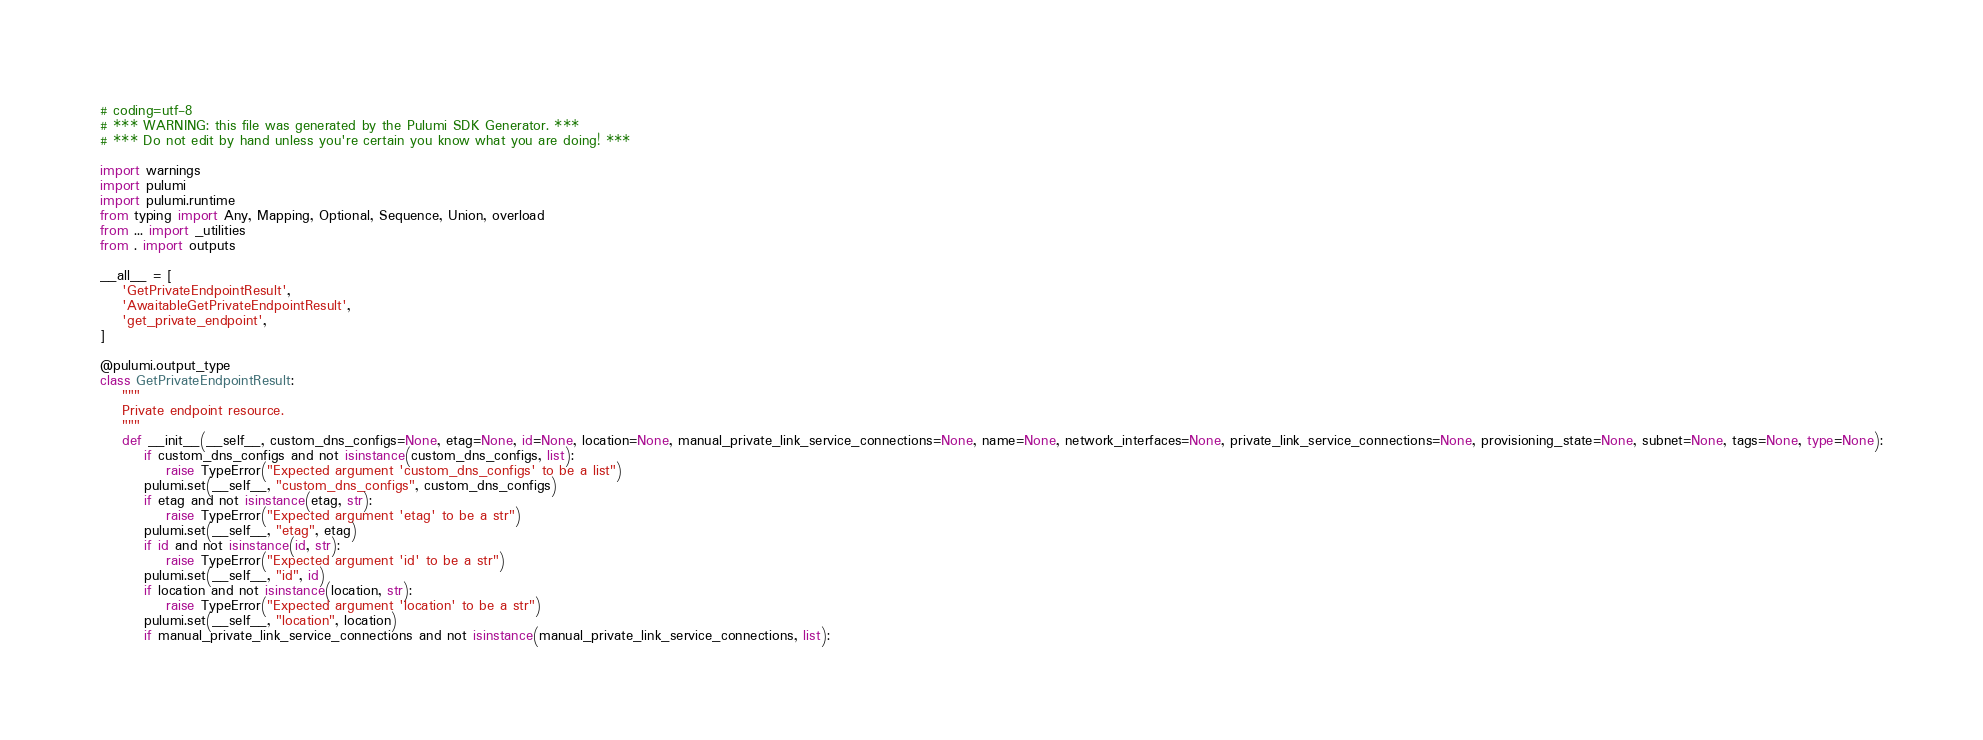Convert code to text. <code><loc_0><loc_0><loc_500><loc_500><_Python_># coding=utf-8
# *** WARNING: this file was generated by the Pulumi SDK Generator. ***
# *** Do not edit by hand unless you're certain you know what you are doing! ***

import warnings
import pulumi
import pulumi.runtime
from typing import Any, Mapping, Optional, Sequence, Union, overload
from ... import _utilities
from . import outputs

__all__ = [
    'GetPrivateEndpointResult',
    'AwaitableGetPrivateEndpointResult',
    'get_private_endpoint',
]

@pulumi.output_type
class GetPrivateEndpointResult:
    """
    Private endpoint resource.
    """
    def __init__(__self__, custom_dns_configs=None, etag=None, id=None, location=None, manual_private_link_service_connections=None, name=None, network_interfaces=None, private_link_service_connections=None, provisioning_state=None, subnet=None, tags=None, type=None):
        if custom_dns_configs and not isinstance(custom_dns_configs, list):
            raise TypeError("Expected argument 'custom_dns_configs' to be a list")
        pulumi.set(__self__, "custom_dns_configs", custom_dns_configs)
        if etag and not isinstance(etag, str):
            raise TypeError("Expected argument 'etag' to be a str")
        pulumi.set(__self__, "etag", etag)
        if id and not isinstance(id, str):
            raise TypeError("Expected argument 'id' to be a str")
        pulumi.set(__self__, "id", id)
        if location and not isinstance(location, str):
            raise TypeError("Expected argument 'location' to be a str")
        pulumi.set(__self__, "location", location)
        if manual_private_link_service_connections and not isinstance(manual_private_link_service_connections, list):</code> 